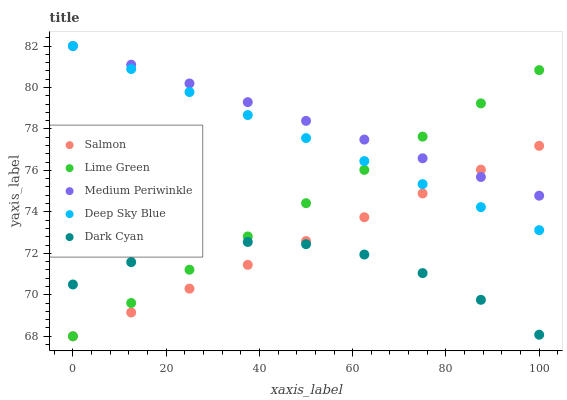Does Dark Cyan have the minimum area under the curve?
Answer yes or no. Yes. Does Medium Periwinkle have the maximum area under the curve?
Answer yes or no. Yes. Does Lime Green have the minimum area under the curve?
Answer yes or no. No. Does Lime Green have the maximum area under the curve?
Answer yes or no. No. Is Salmon the smoothest?
Answer yes or no. Yes. Is Dark Cyan the roughest?
Answer yes or no. Yes. Is Lime Green the smoothest?
Answer yes or no. No. Is Lime Green the roughest?
Answer yes or no. No. Does Lime Green have the lowest value?
Answer yes or no. Yes. Does Deep Sky Blue have the lowest value?
Answer yes or no. No. Does Medium Periwinkle have the highest value?
Answer yes or no. Yes. Does Lime Green have the highest value?
Answer yes or no. No. Is Dark Cyan less than Medium Periwinkle?
Answer yes or no. Yes. Is Medium Periwinkle greater than Dark Cyan?
Answer yes or no. Yes. Does Dark Cyan intersect Lime Green?
Answer yes or no. Yes. Is Dark Cyan less than Lime Green?
Answer yes or no. No. Is Dark Cyan greater than Lime Green?
Answer yes or no. No. Does Dark Cyan intersect Medium Periwinkle?
Answer yes or no. No. 